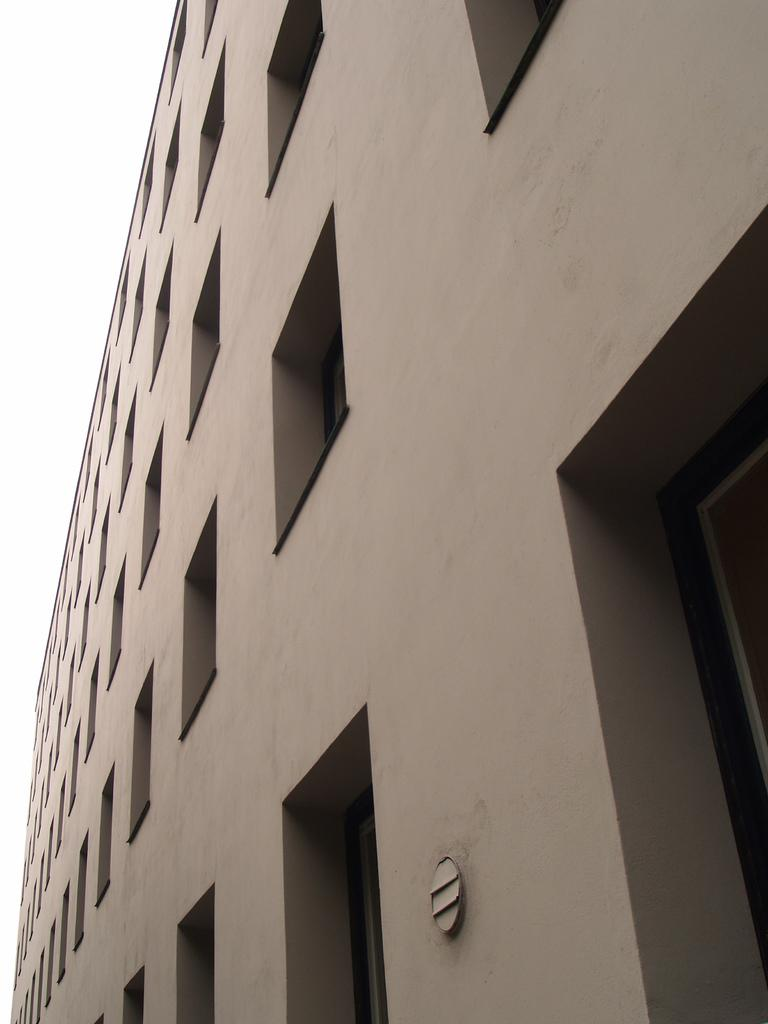What is the main subject of the picture? The main subject of the picture is a building. What specific features can be observed on the building? The building has windows. What can be seen in the background of the picture? There is sky visible in the background of the picture. What type of pear can be seen causing disgust in the image? There is no pear or any indication of disgust present in the image. 